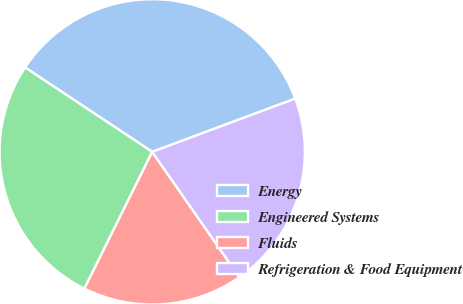<chart> <loc_0><loc_0><loc_500><loc_500><pie_chart><fcel>Energy<fcel>Engineered Systems<fcel>Fluids<fcel>Refrigeration & Food Equipment<nl><fcel>35.0%<fcel>27.0%<fcel>17.0%<fcel>21.0%<nl></chart> 